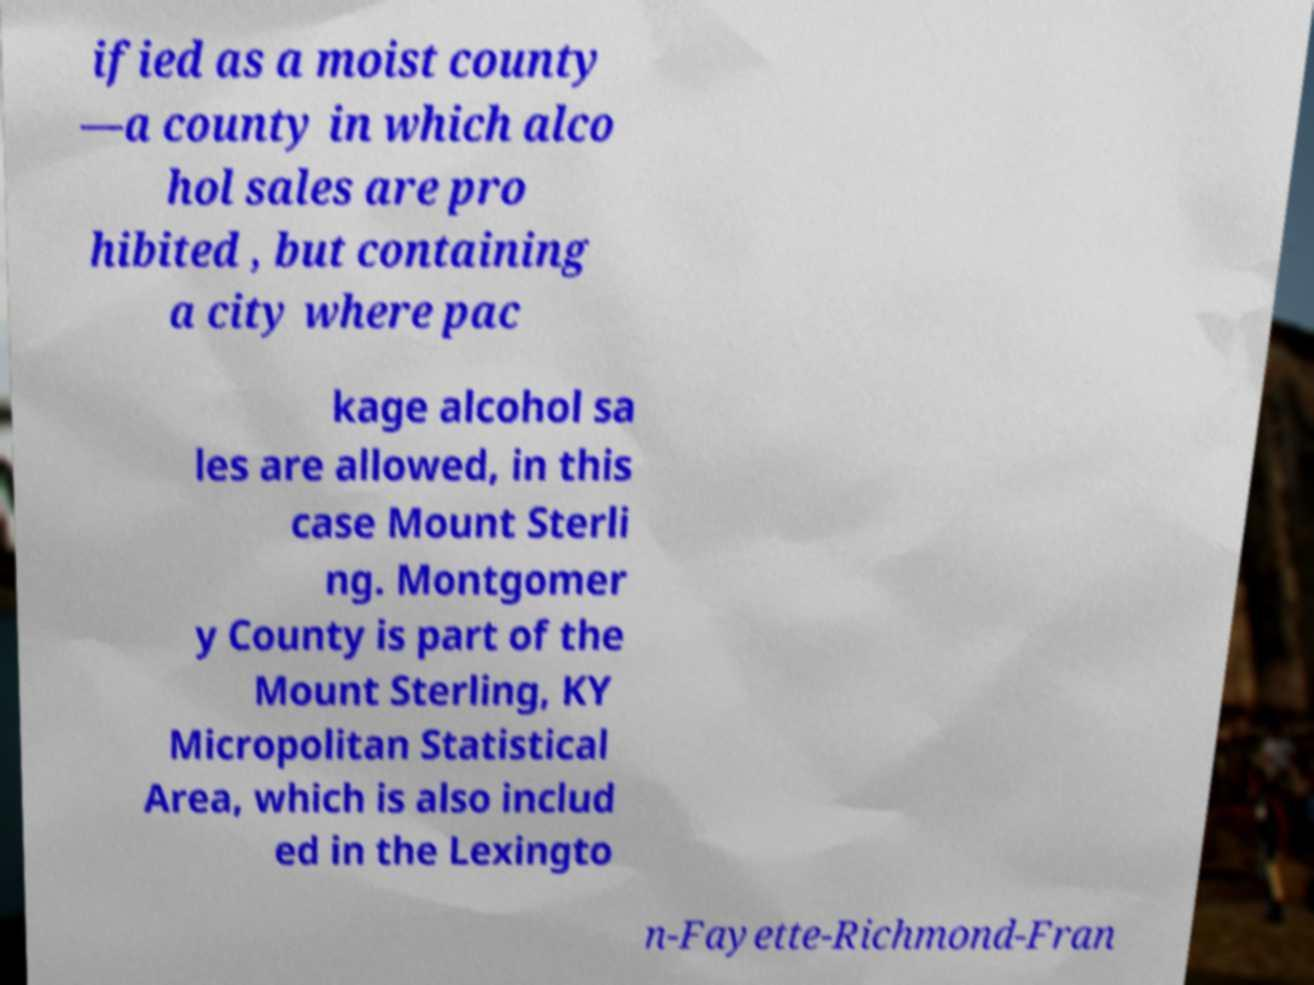Can you accurately transcribe the text from the provided image for me? ified as a moist county —a county in which alco hol sales are pro hibited , but containing a city where pac kage alcohol sa les are allowed, in this case Mount Sterli ng. Montgomer y County is part of the Mount Sterling, KY Micropolitan Statistical Area, which is also includ ed in the Lexingto n-Fayette-Richmond-Fran 